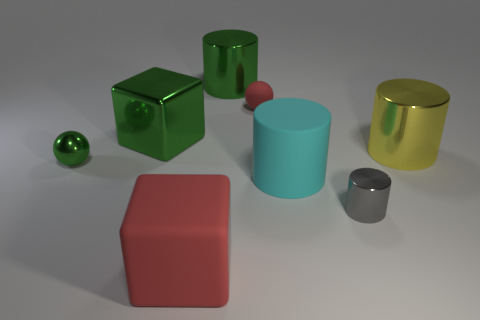Do the tiny matte ball and the big rubber block have the same color?
Give a very brief answer. Yes. What material is the green cylinder that is the same size as the cyan matte object?
Make the answer very short. Metal. There is a thing that is to the left of the big yellow cylinder and on the right side of the large cyan rubber cylinder; what material is it made of?
Offer a very short reply. Metal. There is a big metallic cylinder on the left side of the yellow metal thing; is there a large red rubber block behind it?
Your answer should be compact. No. There is a cylinder that is behind the tiny gray shiny cylinder and in front of the yellow metal cylinder; what is its size?
Offer a terse response. Large. How many yellow things are matte things or blocks?
Keep it short and to the point. 0. What is the shape of the green metal thing that is the same size as the red rubber sphere?
Make the answer very short. Sphere. How many other objects are the same color as the matte ball?
Give a very brief answer. 1. There is a sphere that is in front of the big shiny cylinder in front of the small red rubber ball; what size is it?
Offer a terse response. Small. Are the tiny gray cylinder that is to the right of the large matte cylinder and the big cyan object made of the same material?
Ensure brevity in your answer.  No. 